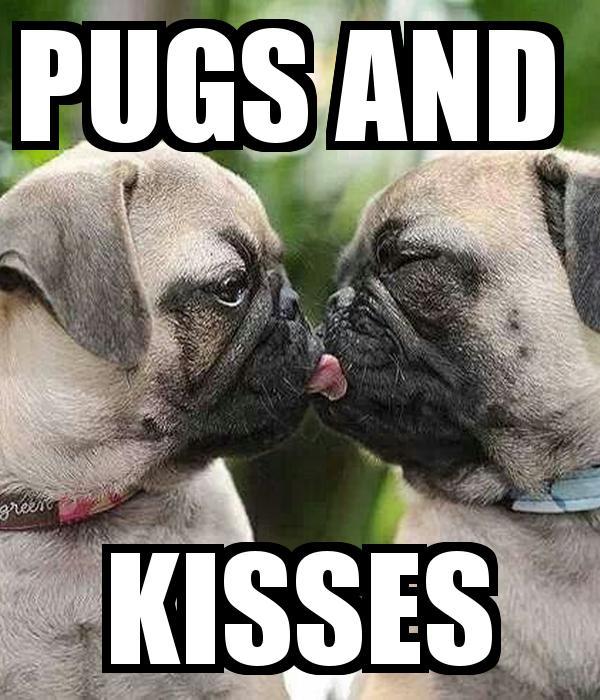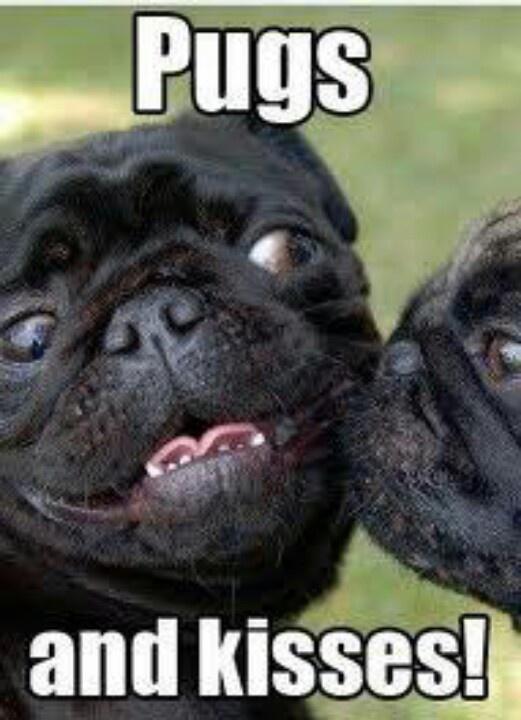The first image is the image on the left, the second image is the image on the right. Analyze the images presented: Is the assertion "The left and right image contains the same number of dogs." valid? Answer yes or no. Yes. 